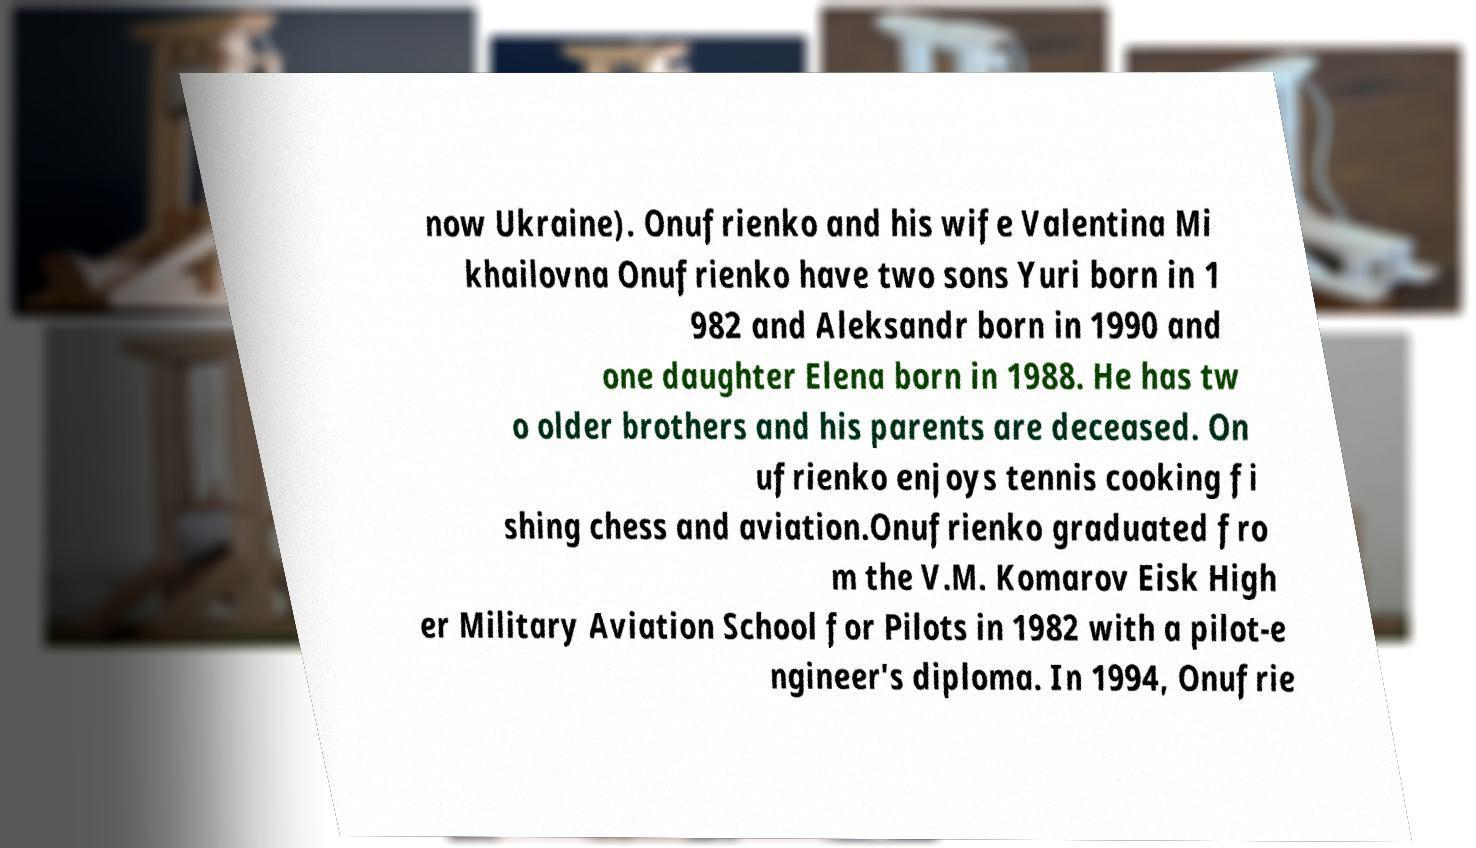Can you read and provide the text displayed in the image?This photo seems to have some interesting text. Can you extract and type it out for me? now Ukraine). Onufrienko and his wife Valentina Mi khailovna Onufrienko have two sons Yuri born in 1 982 and Aleksandr born in 1990 and one daughter Elena born in 1988. He has tw o older brothers and his parents are deceased. On ufrienko enjoys tennis cooking fi shing chess and aviation.Onufrienko graduated fro m the V.M. Komarov Eisk High er Military Aviation School for Pilots in 1982 with a pilot-e ngineer's diploma. In 1994, Onufrie 